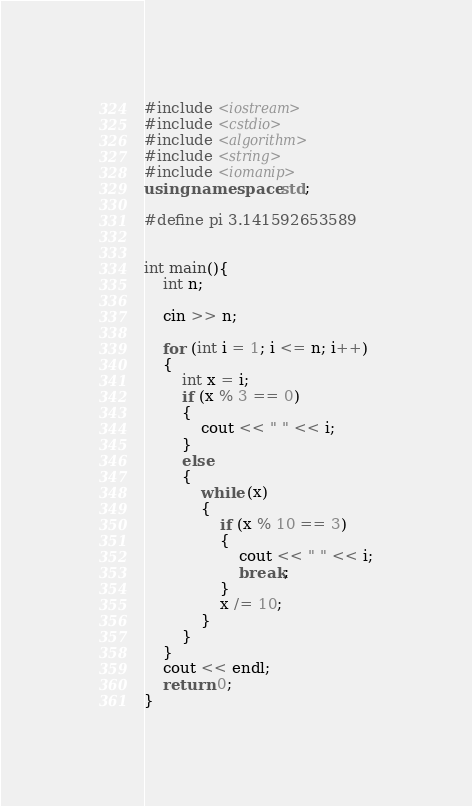Convert code to text. <code><loc_0><loc_0><loc_500><loc_500><_C++_>#include <iostream>
#include <cstdio>
#include <algorithm>
#include <string>
#include <iomanip>
using namespace std;

#define pi 3.141592653589


int main(){
	int n;
	
	cin >> n;

	for (int i = 1; i <= n; i++)
	{
		int x = i;
		if (x % 3 == 0)
		{
			cout << " " << i;
		}
		else
		{
			while (x)
			{
				if (x % 10 == 3)
				{
					cout << " " << i;
					break;
				}
				x /= 10;
			}
		}
	}
	cout << endl;
	return 0;
}</code> 